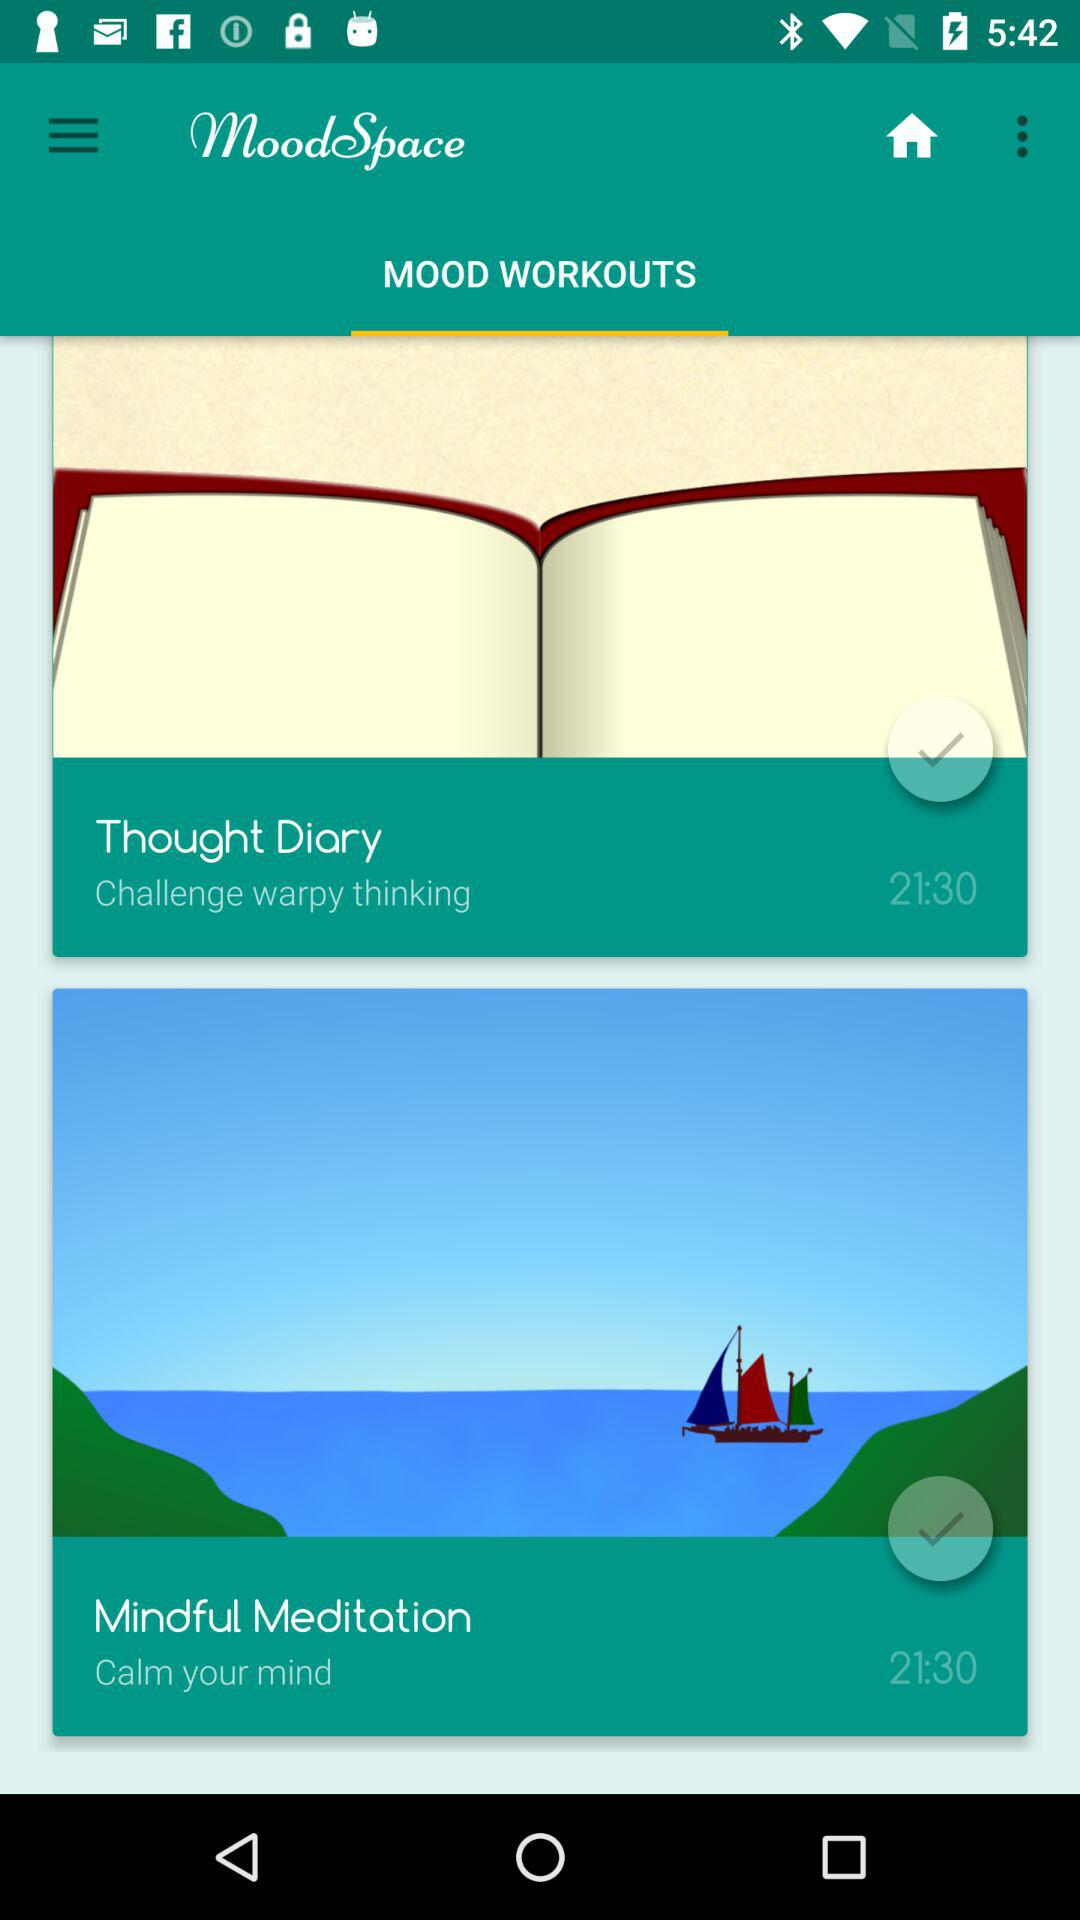What is the application name? The application name is "MoodSpace". 